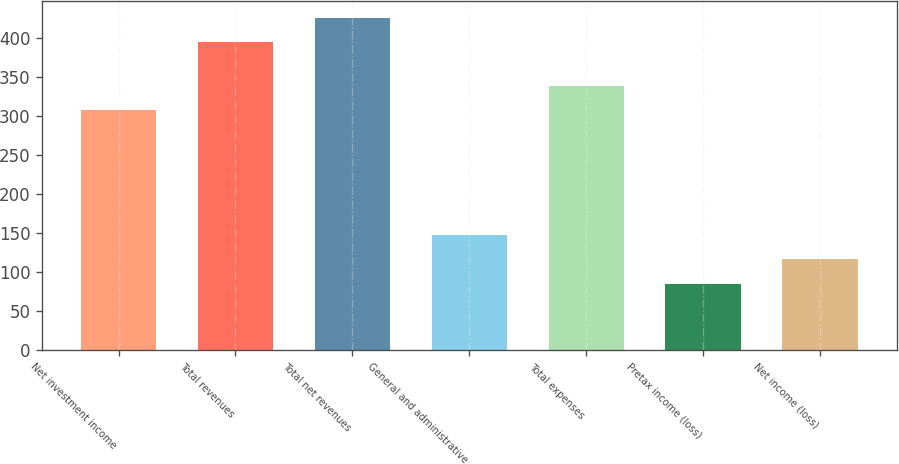<chart> <loc_0><loc_0><loc_500><loc_500><bar_chart><fcel>Net investment income<fcel>Total revenues<fcel>Total net revenues<fcel>General and administrative<fcel>Total expenses<fcel>Pretax income (loss)<fcel>Net income (loss)<nl><fcel>308<fcel>395<fcel>426<fcel>147<fcel>339<fcel>85<fcel>116<nl></chart> 